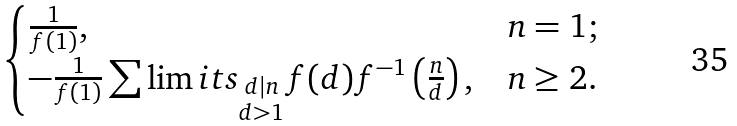<formula> <loc_0><loc_0><loc_500><loc_500>\begin{cases} \frac { 1 } { f ( 1 ) } , & n = 1 ; \\ - \frac { 1 } { f ( 1 ) } \sum \lim i t s _ { \substack { d | n \\ d > 1 } } f ( d ) f ^ { - 1 } \left ( \frac { n } { d } \right ) , & n \geq 2 . \end{cases}</formula> 